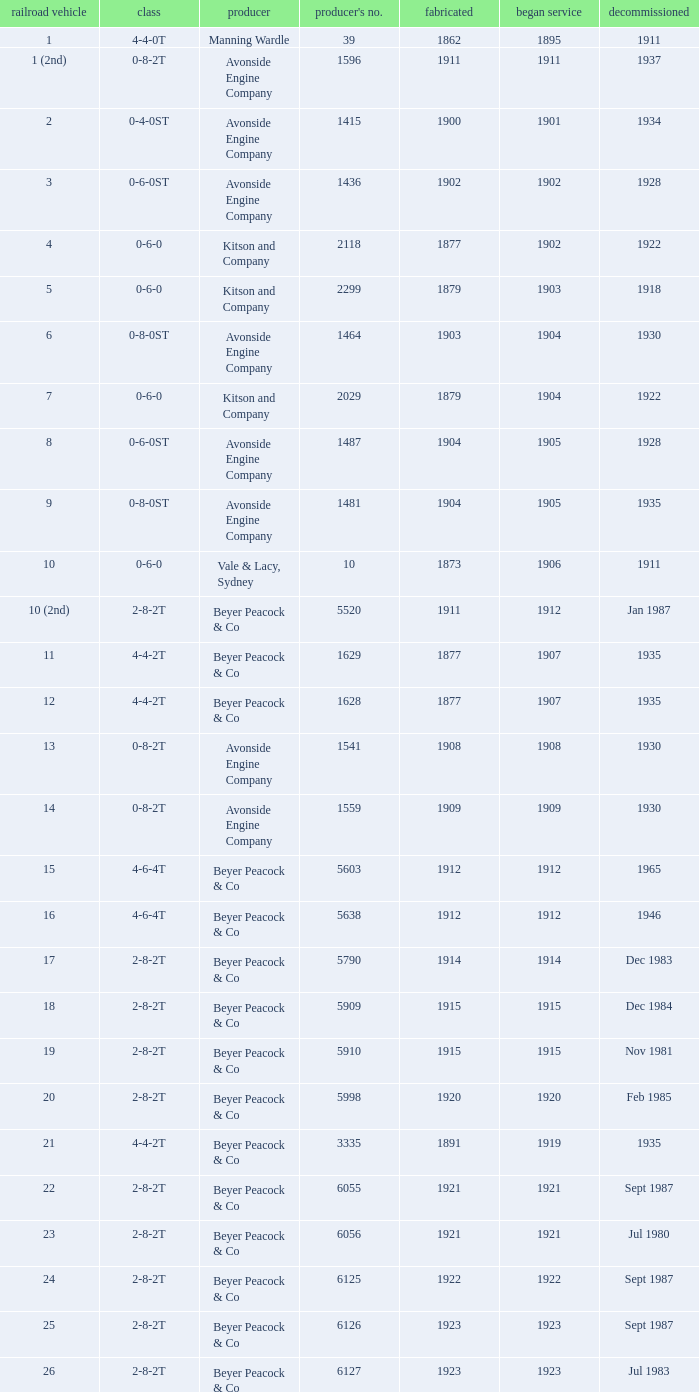How many years entered service when there were 13 locomotives? 1.0. 